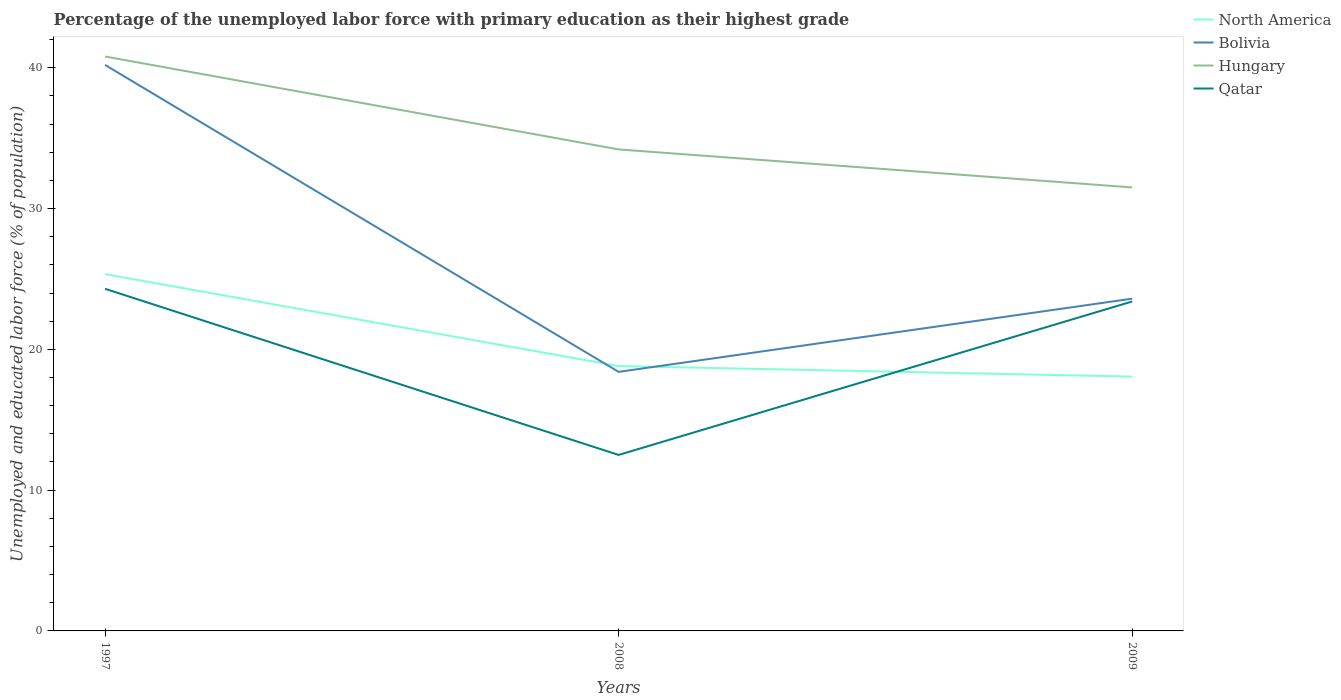How many different coloured lines are there?
Offer a very short reply. 4. Is the number of lines equal to the number of legend labels?
Offer a very short reply. Yes. Across all years, what is the maximum percentage of the unemployed labor force with primary education in North America?
Your answer should be compact. 18.06. In which year was the percentage of the unemployed labor force with primary education in Qatar maximum?
Provide a succinct answer. 2008. What is the total percentage of the unemployed labor force with primary education in North America in the graph?
Provide a short and direct response. 0.75. What is the difference between the highest and the second highest percentage of the unemployed labor force with primary education in Qatar?
Provide a short and direct response. 11.8. What is the difference between the highest and the lowest percentage of the unemployed labor force with primary education in Bolivia?
Offer a terse response. 1. Is the percentage of the unemployed labor force with primary education in North America strictly greater than the percentage of the unemployed labor force with primary education in Hungary over the years?
Your answer should be compact. Yes. How many years are there in the graph?
Keep it short and to the point. 3. What is the difference between two consecutive major ticks on the Y-axis?
Your response must be concise. 10. What is the title of the graph?
Your answer should be compact. Percentage of the unemployed labor force with primary education as their highest grade. What is the label or title of the X-axis?
Provide a short and direct response. Years. What is the label or title of the Y-axis?
Offer a terse response. Unemployed and educated labor force (% of population). What is the Unemployed and educated labor force (% of population) of North America in 1997?
Provide a short and direct response. 25.34. What is the Unemployed and educated labor force (% of population) of Bolivia in 1997?
Make the answer very short. 40.2. What is the Unemployed and educated labor force (% of population) of Hungary in 1997?
Offer a very short reply. 40.8. What is the Unemployed and educated labor force (% of population) of Qatar in 1997?
Provide a succinct answer. 24.3. What is the Unemployed and educated labor force (% of population) in North America in 2008?
Provide a short and direct response. 18.81. What is the Unemployed and educated labor force (% of population) of Bolivia in 2008?
Provide a short and direct response. 18.4. What is the Unemployed and educated labor force (% of population) in Hungary in 2008?
Make the answer very short. 34.2. What is the Unemployed and educated labor force (% of population) of Qatar in 2008?
Provide a succinct answer. 12.5. What is the Unemployed and educated labor force (% of population) in North America in 2009?
Offer a very short reply. 18.06. What is the Unemployed and educated labor force (% of population) in Bolivia in 2009?
Keep it short and to the point. 23.6. What is the Unemployed and educated labor force (% of population) of Hungary in 2009?
Make the answer very short. 31.5. What is the Unemployed and educated labor force (% of population) in Qatar in 2009?
Your answer should be compact. 23.4. Across all years, what is the maximum Unemployed and educated labor force (% of population) of North America?
Make the answer very short. 25.34. Across all years, what is the maximum Unemployed and educated labor force (% of population) in Bolivia?
Keep it short and to the point. 40.2. Across all years, what is the maximum Unemployed and educated labor force (% of population) of Hungary?
Provide a short and direct response. 40.8. Across all years, what is the maximum Unemployed and educated labor force (% of population) of Qatar?
Provide a succinct answer. 24.3. Across all years, what is the minimum Unemployed and educated labor force (% of population) of North America?
Make the answer very short. 18.06. Across all years, what is the minimum Unemployed and educated labor force (% of population) in Bolivia?
Give a very brief answer. 18.4. Across all years, what is the minimum Unemployed and educated labor force (% of population) in Hungary?
Your answer should be compact. 31.5. What is the total Unemployed and educated labor force (% of population) of North America in the graph?
Give a very brief answer. 62.22. What is the total Unemployed and educated labor force (% of population) in Bolivia in the graph?
Keep it short and to the point. 82.2. What is the total Unemployed and educated labor force (% of population) in Hungary in the graph?
Your response must be concise. 106.5. What is the total Unemployed and educated labor force (% of population) of Qatar in the graph?
Your answer should be very brief. 60.2. What is the difference between the Unemployed and educated labor force (% of population) in North America in 1997 and that in 2008?
Provide a succinct answer. 6.53. What is the difference between the Unemployed and educated labor force (% of population) in Bolivia in 1997 and that in 2008?
Your answer should be compact. 21.8. What is the difference between the Unemployed and educated labor force (% of population) in North America in 1997 and that in 2009?
Ensure brevity in your answer.  7.28. What is the difference between the Unemployed and educated labor force (% of population) in Hungary in 1997 and that in 2009?
Your answer should be compact. 9.3. What is the difference between the Unemployed and educated labor force (% of population) in Qatar in 1997 and that in 2009?
Make the answer very short. 0.9. What is the difference between the Unemployed and educated labor force (% of population) of North America in 2008 and that in 2009?
Keep it short and to the point. 0.75. What is the difference between the Unemployed and educated labor force (% of population) of Bolivia in 2008 and that in 2009?
Your answer should be compact. -5.2. What is the difference between the Unemployed and educated labor force (% of population) of North America in 1997 and the Unemployed and educated labor force (% of population) of Bolivia in 2008?
Your answer should be compact. 6.94. What is the difference between the Unemployed and educated labor force (% of population) of North America in 1997 and the Unemployed and educated labor force (% of population) of Hungary in 2008?
Your answer should be compact. -8.86. What is the difference between the Unemployed and educated labor force (% of population) in North America in 1997 and the Unemployed and educated labor force (% of population) in Qatar in 2008?
Offer a very short reply. 12.84. What is the difference between the Unemployed and educated labor force (% of population) of Bolivia in 1997 and the Unemployed and educated labor force (% of population) of Hungary in 2008?
Your response must be concise. 6. What is the difference between the Unemployed and educated labor force (% of population) in Bolivia in 1997 and the Unemployed and educated labor force (% of population) in Qatar in 2008?
Ensure brevity in your answer.  27.7. What is the difference between the Unemployed and educated labor force (% of population) of Hungary in 1997 and the Unemployed and educated labor force (% of population) of Qatar in 2008?
Provide a short and direct response. 28.3. What is the difference between the Unemployed and educated labor force (% of population) of North America in 1997 and the Unemployed and educated labor force (% of population) of Bolivia in 2009?
Your answer should be compact. 1.74. What is the difference between the Unemployed and educated labor force (% of population) in North America in 1997 and the Unemployed and educated labor force (% of population) in Hungary in 2009?
Your answer should be compact. -6.16. What is the difference between the Unemployed and educated labor force (% of population) in North America in 1997 and the Unemployed and educated labor force (% of population) in Qatar in 2009?
Give a very brief answer. 1.94. What is the difference between the Unemployed and educated labor force (% of population) of Bolivia in 1997 and the Unemployed and educated labor force (% of population) of Qatar in 2009?
Your answer should be very brief. 16.8. What is the difference between the Unemployed and educated labor force (% of population) in Hungary in 1997 and the Unemployed and educated labor force (% of population) in Qatar in 2009?
Your response must be concise. 17.4. What is the difference between the Unemployed and educated labor force (% of population) of North America in 2008 and the Unemployed and educated labor force (% of population) of Bolivia in 2009?
Offer a terse response. -4.79. What is the difference between the Unemployed and educated labor force (% of population) in North America in 2008 and the Unemployed and educated labor force (% of population) in Hungary in 2009?
Provide a short and direct response. -12.69. What is the difference between the Unemployed and educated labor force (% of population) of North America in 2008 and the Unemployed and educated labor force (% of population) of Qatar in 2009?
Your answer should be very brief. -4.59. What is the difference between the Unemployed and educated labor force (% of population) of Bolivia in 2008 and the Unemployed and educated labor force (% of population) of Qatar in 2009?
Provide a short and direct response. -5. What is the difference between the Unemployed and educated labor force (% of population) of Hungary in 2008 and the Unemployed and educated labor force (% of population) of Qatar in 2009?
Make the answer very short. 10.8. What is the average Unemployed and educated labor force (% of population) of North America per year?
Make the answer very short. 20.74. What is the average Unemployed and educated labor force (% of population) of Bolivia per year?
Your response must be concise. 27.4. What is the average Unemployed and educated labor force (% of population) of Hungary per year?
Your answer should be very brief. 35.5. What is the average Unemployed and educated labor force (% of population) of Qatar per year?
Provide a short and direct response. 20.07. In the year 1997, what is the difference between the Unemployed and educated labor force (% of population) in North America and Unemployed and educated labor force (% of population) in Bolivia?
Make the answer very short. -14.86. In the year 1997, what is the difference between the Unemployed and educated labor force (% of population) of North America and Unemployed and educated labor force (% of population) of Hungary?
Provide a succinct answer. -15.46. In the year 1997, what is the difference between the Unemployed and educated labor force (% of population) of North America and Unemployed and educated labor force (% of population) of Qatar?
Your answer should be very brief. 1.04. In the year 1997, what is the difference between the Unemployed and educated labor force (% of population) in Bolivia and Unemployed and educated labor force (% of population) in Hungary?
Offer a terse response. -0.6. In the year 1997, what is the difference between the Unemployed and educated labor force (% of population) in Hungary and Unemployed and educated labor force (% of population) in Qatar?
Give a very brief answer. 16.5. In the year 2008, what is the difference between the Unemployed and educated labor force (% of population) in North America and Unemployed and educated labor force (% of population) in Bolivia?
Your answer should be very brief. 0.41. In the year 2008, what is the difference between the Unemployed and educated labor force (% of population) of North America and Unemployed and educated labor force (% of population) of Hungary?
Ensure brevity in your answer.  -15.39. In the year 2008, what is the difference between the Unemployed and educated labor force (% of population) of North America and Unemployed and educated labor force (% of population) of Qatar?
Make the answer very short. 6.31. In the year 2008, what is the difference between the Unemployed and educated labor force (% of population) of Bolivia and Unemployed and educated labor force (% of population) of Hungary?
Your response must be concise. -15.8. In the year 2008, what is the difference between the Unemployed and educated labor force (% of population) in Bolivia and Unemployed and educated labor force (% of population) in Qatar?
Ensure brevity in your answer.  5.9. In the year 2008, what is the difference between the Unemployed and educated labor force (% of population) of Hungary and Unemployed and educated labor force (% of population) of Qatar?
Offer a terse response. 21.7. In the year 2009, what is the difference between the Unemployed and educated labor force (% of population) in North America and Unemployed and educated labor force (% of population) in Bolivia?
Ensure brevity in your answer.  -5.54. In the year 2009, what is the difference between the Unemployed and educated labor force (% of population) of North America and Unemployed and educated labor force (% of population) of Hungary?
Provide a short and direct response. -13.44. In the year 2009, what is the difference between the Unemployed and educated labor force (% of population) of North America and Unemployed and educated labor force (% of population) of Qatar?
Ensure brevity in your answer.  -5.34. In the year 2009, what is the difference between the Unemployed and educated labor force (% of population) of Bolivia and Unemployed and educated labor force (% of population) of Qatar?
Keep it short and to the point. 0.2. What is the ratio of the Unemployed and educated labor force (% of population) of North America in 1997 to that in 2008?
Your answer should be very brief. 1.35. What is the ratio of the Unemployed and educated labor force (% of population) in Bolivia in 1997 to that in 2008?
Your answer should be very brief. 2.18. What is the ratio of the Unemployed and educated labor force (% of population) of Hungary in 1997 to that in 2008?
Your answer should be compact. 1.19. What is the ratio of the Unemployed and educated labor force (% of population) of Qatar in 1997 to that in 2008?
Provide a succinct answer. 1.94. What is the ratio of the Unemployed and educated labor force (% of population) of North America in 1997 to that in 2009?
Your answer should be compact. 1.4. What is the ratio of the Unemployed and educated labor force (% of population) in Bolivia in 1997 to that in 2009?
Provide a succinct answer. 1.7. What is the ratio of the Unemployed and educated labor force (% of population) of Hungary in 1997 to that in 2009?
Provide a succinct answer. 1.3. What is the ratio of the Unemployed and educated labor force (% of population) in North America in 2008 to that in 2009?
Offer a terse response. 1.04. What is the ratio of the Unemployed and educated labor force (% of population) in Bolivia in 2008 to that in 2009?
Offer a terse response. 0.78. What is the ratio of the Unemployed and educated labor force (% of population) of Hungary in 2008 to that in 2009?
Your answer should be very brief. 1.09. What is the ratio of the Unemployed and educated labor force (% of population) in Qatar in 2008 to that in 2009?
Keep it short and to the point. 0.53. What is the difference between the highest and the second highest Unemployed and educated labor force (% of population) of North America?
Provide a succinct answer. 6.53. What is the difference between the highest and the second highest Unemployed and educated labor force (% of population) of Hungary?
Offer a terse response. 6.6. What is the difference between the highest and the second highest Unemployed and educated labor force (% of population) in Qatar?
Your response must be concise. 0.9. What is the difference between the highest and the lowest Unemployed and educated labor force (% of population) of North America?
Offer a very short reply. 7.28. What is the difference between the highest and the lowest Unemployed and educated labor force (% of population) in Bolivia?
Keep it short and to the point. 21.8. 